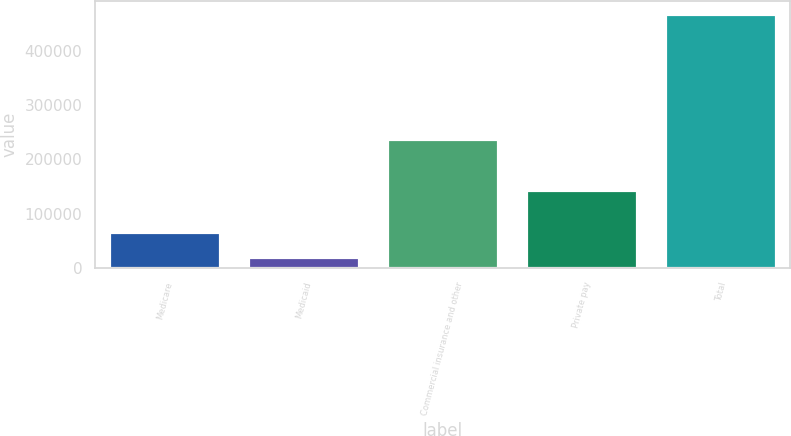Convert chart. <chart><loc_0><loc_0><loc_500><loc_500><bar_chart><fcel>Medicare<fcel>Medicaid<fcel>Commercial insurance and other<fcel>Private pay<fcel>Total<nl><fcel>66125<fcel>20710<fcel>237587<fcel>143683<fcel>468105<nl></chart> 